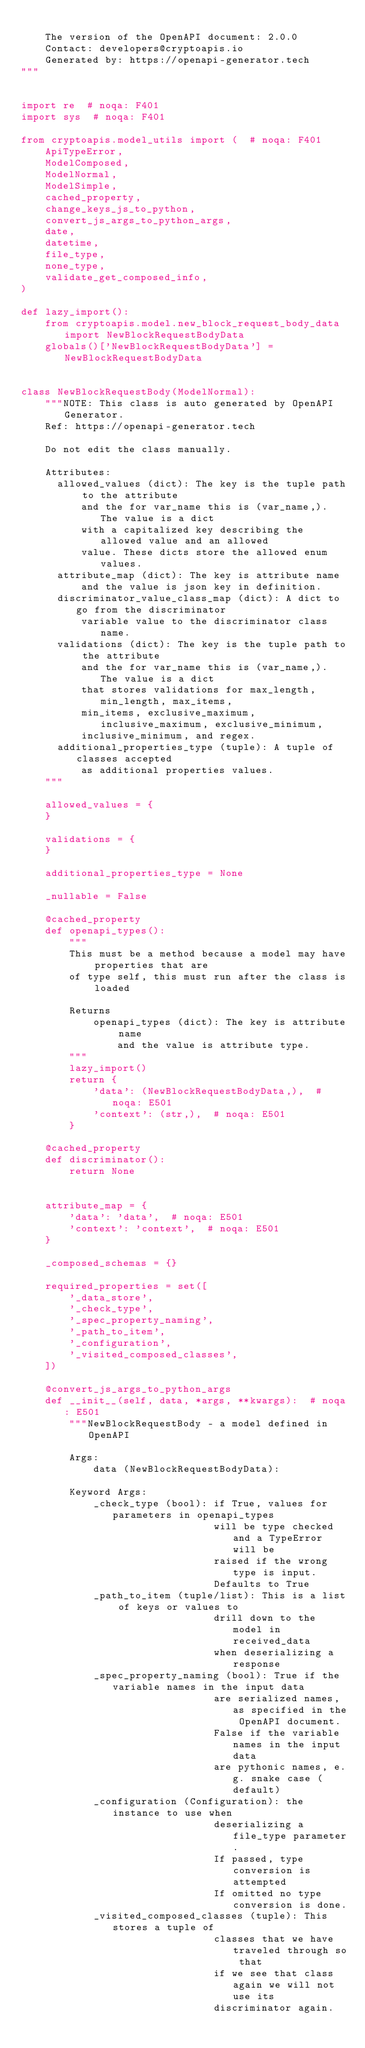Convert code to text. <code><loc_0><loc_0><loc_500><loc_500><_Python_>
    The version of the OpenAPI document: 2.0.0
    Contact: developers@cryptoapis.io
    Generated by: https://openapi-generator.tech
"""


import re  # noqa: F401
import sys  # noqa: F401

from cryptoapis.model_utils import (  # noqa: F401
    ApiTypeError,
    ModelComposed,
    ModelNormal,
    ModelSimple,
    cached_property,
    change_keys_js_to_python,
    convert_js_args_to_python_args,
    date,
    datetime,
    file_type,
    none_type,
    validate_get_composed_info,
)

def lazy_import():
    from cryptoapis.model.new_block_request_body_data import NewBlockRequestBodyData
    globals()['NewBlockRequestBodyData'] = NewBlockRequestBodyData


class NewBlockRequestBody(ModelNormal):
    """NOTE: This class is auto generated by OpenAPI Generator.
    Ref: https://openapi-generator.tech

    Do not edit the class manually.

    Attributes:
      allowed_values (dict): The key is the tuple path to the attribute
          and the for var_name this is (var_name,). The value is a dict
          with a capitalized key describing the allowed value and an allowed
          value. These dicts store the allowed enum values.
      attribute_map (dict): The key is attribute name
          and the value is json key in definition.
      discriminator_value_class_map (dict): A dict to go from the discriminator
          variable value to the discriminator class name.
      validations (dict): The key is the tuple path to the attribute
          and the for var_name this is (var_name,). The value is a dict
          that stores validations for max_length, min_length, max_items,
          min_items, exclusive_maximum, inclusive_maximum, exclusive_minimum,
          inclusive_minimum, and regex.
      additional_properties_type (tuple): A tuple of classes accepted
          as additional properties values.
    """

    allowed_values = {
    }

    validations = {
    }

    additional_properties_type = None

    _nullable = False

    @cached_property
    def openapi_types():
        """
        This must be a method because a model may have properties that are
        of type self, this must run after the class is loaded

        Returns
            openapi_types (dict): The key is attribute name
                and the value is attribute type.
        """
        lazy_import()
        return {
            'data': (NewBlockRequestBodyData,),  # noqa: E501
            'context': (str,),  # noqa: E501
        }

    @cached_property
    def discriminator():
        return None


    attribute_map = {
        'data': 'data',  # noqa: E501
        'context': 'context',  # noqa: E501
    }

    _composed_schemas = {}

    required_properties = set([
        '_data_store',
        '_check_type',
        '_spec_property_naming',
        '_path_to_item',
        '_configuration',
        '_visited_composed_classes',
    ])

    @convert_js_args_to_python_args
    def __init__(self, data, *args, **kwargs):  # noqa: E501
        """NewBlockRequestBody - a model defined in OpenAPI

        Args:
            data (NewBlockRequestBodyData):

        Keyword Args:
            _check_type (bool): if True, values for parameters in openapi_types
                                will be type checked and a TypeError will be
                                raised if the wrong type is input.
                                Defaults to True
            _path_to_item (tuple/list): This is a list of keys or values to
                                drill down to the model in received_data
                                when deserializing a response
            _spec_property_naming (bool): True if the variable names in the input data
                                are serialized names, as specified in the OpenAPI document.
                                False if the variable names in the input data
                                are pythonic names, e.g. snake case (default)
            _configuration (Configuration): the instance to use when
                                deserializing a file_type parameter.
                                If passed, type conversion is attempted
                                If omitted no type conversion is done.
            _visited_composed_classes (tuple): This stores a tuple of
                                classes that we have traveled through so that
                                if we see that class again we will not use its
                                discriminator again.</code> 